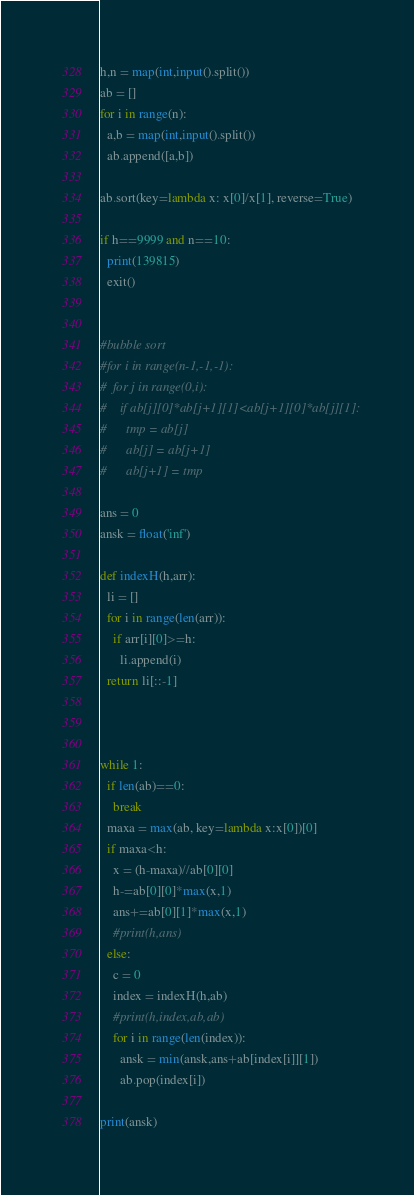Convert code to text. <code><loc_0><loc_0><loc_500><loc_500><_Python_>h,n = map(int,input().split())
ab = []
for i in range(n):
  a,b = map(int,input().split())
  ab.append([a,b])

ab.sort(key=lambda x: x[0]/x[1], reverse=True)

if h==9999 and n==10:
  print(139815)
  exit()


#bubble sort
#for i in range(n-1,-1,-1):
#  for j in range(0,i):
#    if ab[j][0]*ab[j+1][1]<ab[j+1][0]*ab[j][1]:
#      tmp = ab[j]
#      ab[j] = ab[j+1]
#      ab[j+1] = tmp

ans = 0
ansk = float('inf')

def indexH(h,arr):
  li = []
  for i in range(len(arr)):
    if arr[i][0]>=h:
      li.append(i)
  return li[::-1]



while 1:
  if len(ab)==0:
    break
  maxa = max(ab, key=lambda x:x[0])[0]
  if maxa<h:
    x = (h-maxa)//ab[0][0]
    h-=ab[0][0]*max(x,1)
    ans+=ab[0][1]*max(x,1)
    #print(h,ans)
  else:
    c = 0
    index = indexH(h,ab)
    #print(h,index,ab,ab)
    for i in range(len(index)):
      ansk = min(ansk,ans+ab[index[i]][1])
      ab.pop(index[i])

print(ansk)</code> 